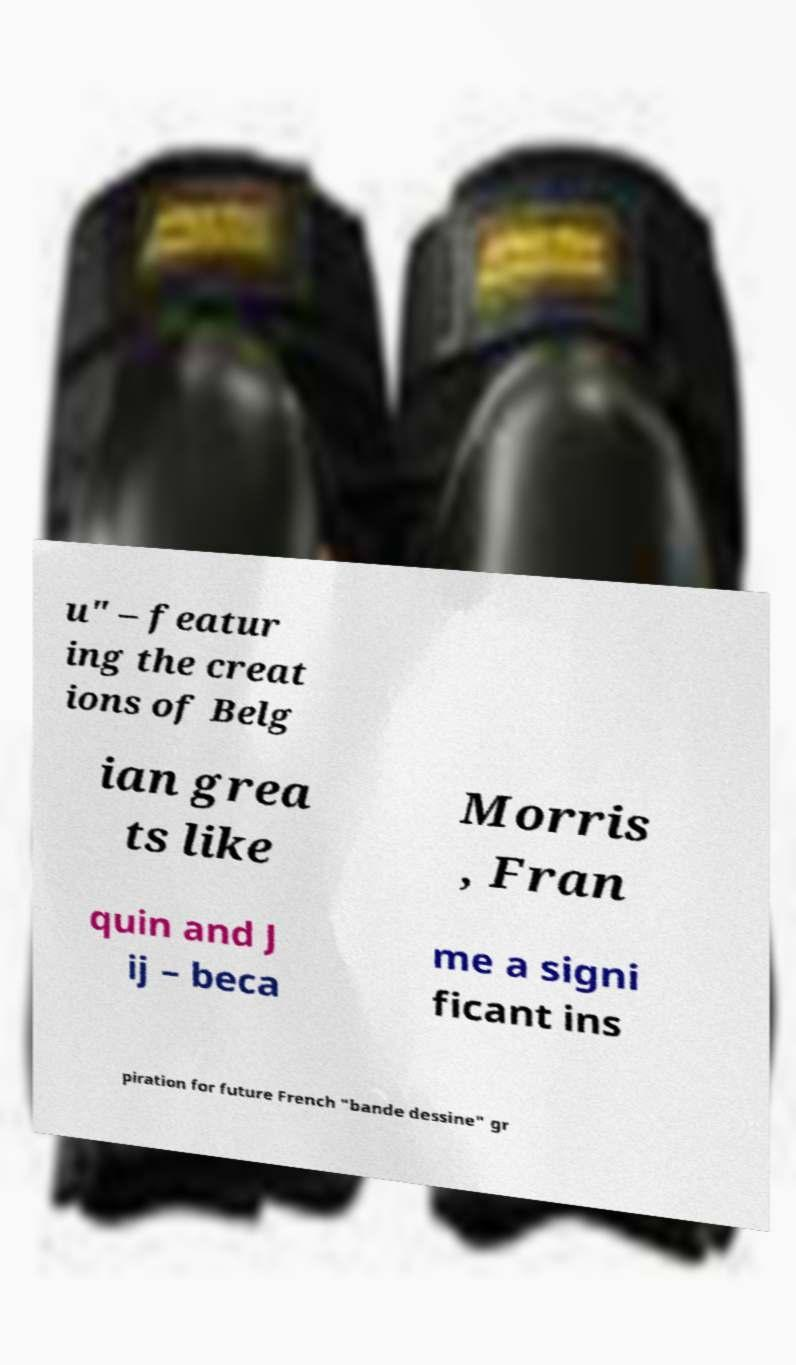I need the written content from this picture converted into text. Can you do that? u" – featur ing the creat ions of Belg ian grea ts like Morris , Fran quin and J ij – beca me a signi ficant ins piration for future French "bande dessine" gr 